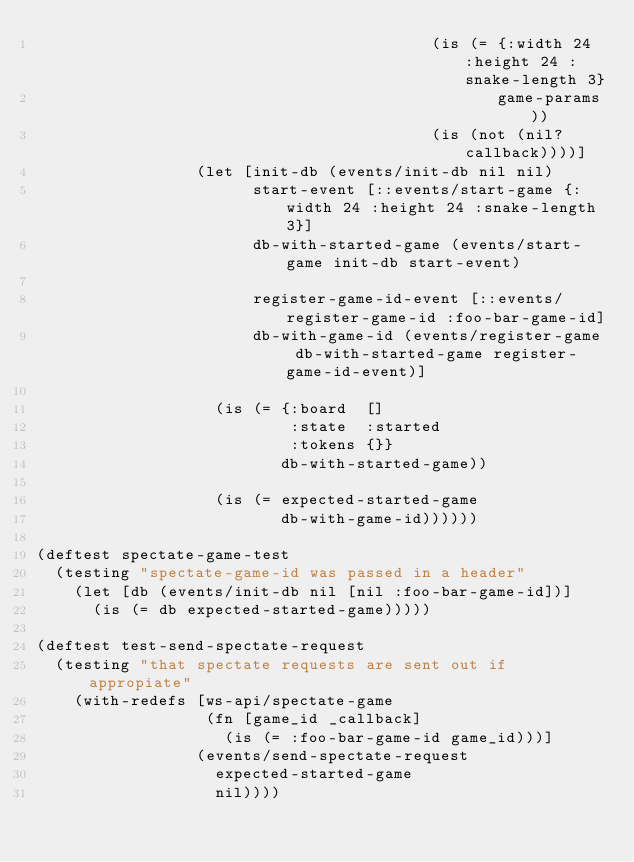Convert code to text. <code><loc_0><loc_0><loc_500><loc_500><_Clojure_>                                          (is (= {:width 24 :height 24 :snake-length 3}
                                                 game-params))
                                          (is (not (nil? callback))))]
                 (let [init-db (events/init-db nil nil)
                       start-event [::events/start-game {:width 24 :height 24 :snake-length 3}]
                       db-with-started-game (events/start-game init-db start-event)

                       register-game-id-event [::events/register-game-id :foo-bar-game-id]
                       db-with-game-id (events/register-game db-with-started-game register-game-id-event)]

                   (is (= {:board  []
                           :state  :started
                           :tokens {}}
                          db-with-started-game))

                   (is (= expected-started-game
                          db-with-game-id))))))

(deftest spectate-game-test
  (testing "spectate-game-id was passed in a header"
    (let [db (events/init-db nil [nil :foo-bar-game-id])]
      (is (= db expected-started-game)))))

(deftest test-send-spectate-request
  (testing "that spectate requests are sent out if appropiate"
    (with-redefs [ws-api/spectate-game
                  (fn [game_id _callback]
                    (is (= :foo-bar-game-id game_id)))]
                 (events/send-spectate-request
                   expected-started-game
                   nil))))</code> 